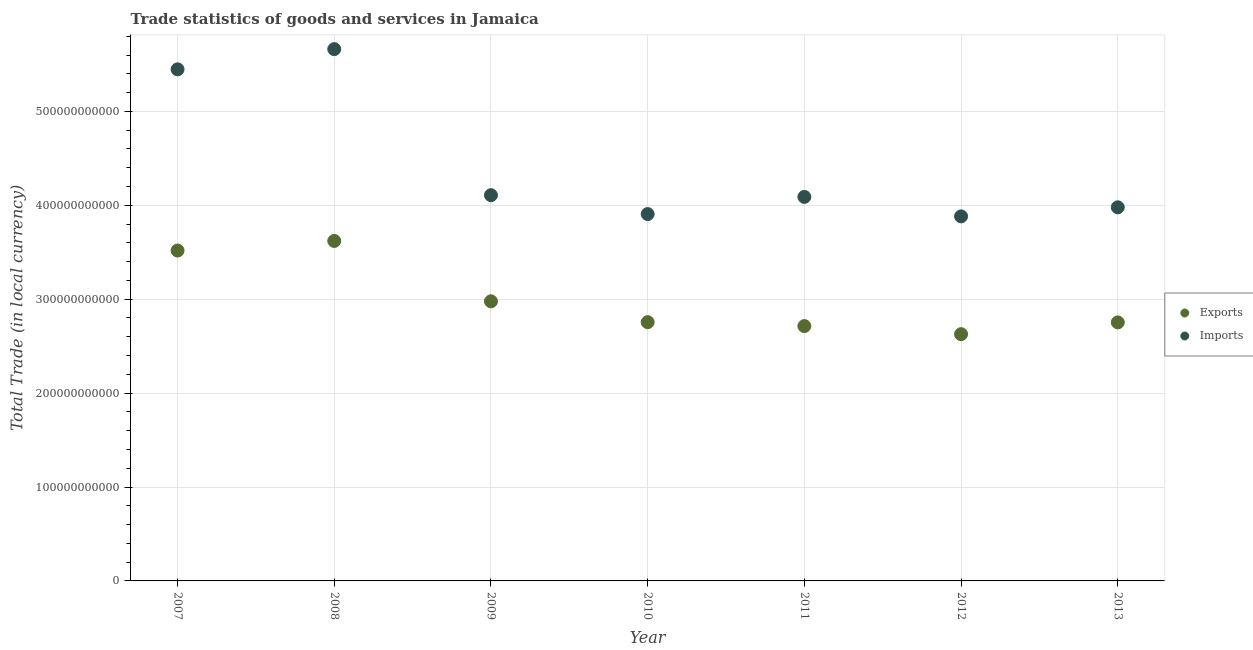What is the export of goods and services in 2009?
Offer a terse response. 2.98e+11. Across all years, what is the maximum export of goods and services?
Your answer should be very brief. 3.62e+11. Across all years, what is the minimum export of goods and services?
Your response must be concise. 2.63e+11. In which year was the imports of goods and services maximum?
Offer a very short reply. 2008. In which year was the imports of goods and services minimum?
Your answer should be very brief. 2012. What is the total export of goods and services in the graph?
Offer a very short reply. 2.10e+12. What is the difference between the export of goods and services in 2009 and that in 2010?
Offer a terse response. 2.22e+1. What is the difference between the imports of goods and services in 2013 and the export of goods and services in 2012?
Offer a terse response. 1.35e+11. What is the average imports of goods and services per year?
Ensure brevity in your answer.  4.44e+11. In the year 2008, what is the difference between the imports of goods and services and export of goods and services?
Give a very brief answer. 2.04e+11. What is the ratio of the imports of goods and services in 2009 to that in 2013?
Offer a very short reply. 1.03. Is the difference between the export of goods and services in 2009 and 2012 greater than the difference between the imports of goods and services in 2009 and 2012?
Offer a terse response. Yes. What is the difference between the highest and the second highest imports of goods and services?
Offer a very short reply. 2.15e+1. What is the difference between the highest and the lowest export of goods and services?
Your answer should be compact. 9.93e+1. Is the imports of goods and services strictly less than the export of goods and services over the years?
Your answer should be compact. No. What is the difference between two consecutive major ticks on the Y-axis?
Provide a succinct answer. 1.00e+11. Does the graph contain any zero values?
Your response must be concise. No. Where does the legend appear in the graph?
Offer a very short reply. Center right. How are the legend labels stacked?
Provide a short and direct response. Vertical. What is the title of the graph?
Offer a terse response. Trade statistics of goods and services in Jamaica. What is the label or title of the X-axis?
Make the answer very short. Year. What is the label or title of the Y-axis?
Ensure brevity in your answer.  Total Trade (in local currency). What is the Total Trade (in local currency) of Exports in 2007?
Offer a very short reply. 3.52e+11. What is the Total Trade (in local currency) of Imports in 2007?
Ensure brevity in your answer.  5.45e+11. What is the Total Trade (in local currency) of Exports in 2008?
Ensure brevity in your answer.  3.62e+11. What is the Total Trade (in local currency) in Imports in 2008?
Your response must be concise. 5.66e+11. What is the Total Trade (in local currency) in Exports in 2009?
Your answer should be compact. 2.98e+11. What is the Total Trade (in local currency) in Imports in 2009?
Make the answer very short. 4.11e+11. What is the Total Trade (in local currency) of Exports in 2010?
Offer a very short reply. 2.76e+11. What is the Total Trade (in local currency) of Imports in 2010?
Offer a terse response. 3.91e+11. What is the Total Trade (in local currency) of Exports in 2011?
Provide a succinct answer. 2.71e+11. What is the Total Trade (in local currency) of Imports in 2011?
Keep it short and to the point. 4.09e+11. What is the Total Trade (in local currency) of Exports in 2012?
Give a very brief answer. 2.63e+11. What is the Total Trade (in local currency) of Imports in 2012?
Make the answer very short. 3.88e+11. What is the Total Trade (in local currency) in Exports in 2013?
Provide a succinct answer. 2.75e+11. What is the Total Trade (in local currency) of Imports in 2013?
Your answer should be compact. 3.98e+11. Across all years, what is the maximum Total Trade (in local currency) of Exports?
Give a very brief answer. 3.62e+11. Across all years, what is the maximum Total Trade (in local currency) of Imports?
Your response must be concise. 5.66e+11. Across all years, what is the minimum Total Trade (in local currency) of Exports?
Offer a very short reply. 2.63e+11. Across all years, what is the minimum Total Trade (in local currency) in Imports?
Your response must be concise. 3.88e+11. What is the total Total Trade (in local currency) in Exports in the graph?
Offer a very short reply. 2.10e+12. What is the total Total Trade (in local currency) of Imports in the graph?
Ensure brevity in your answer.  3.11e+12. What is the difference between the Total Trade (in local currency) in Exports in 2007 and that in 2008?
Ensure brevity in your answer.  -1.02e+1. What is the difference between the Total Trade (in local currency) of Imports in 2007 and that in 2008?
Offer a very short reply. -2.15e+1. What is the difference between the Total Trade (in local currency) in Exports in 2007 and that in 2009?
Offer a very short reply. 5.41e+1. What is the difference between the Total Trade (in local currency) of Imports in 2007 and that in 2009?
Provide a succinct answer. 1.34e+11. What is the difference between the Total Trade (in local currency) of Exports in 2007 and that in 2010?
Offer a very short reply. 7.63e+1. What is the difference between the Total Trade (in local currency) in Imports in 2007 and that in 2010?
Keep it short and to the point. 1.54e+11. What is the difference between the Total Trade (in local currency) of Exports in 2007 and that in 2011?
Provide a short and direct response. 8.05e+1. What is the difference between the Total Trade (in local currency) in Imports in 2007 and that in 2011?
Your answer should be very brief. 1.36e+11. What is the difference between the Total Trade (in local currency) in Exports in 2007 and that in 2012?
Your answer should be very brief. 8.91e+1. What is the difference between the Total Trade (in local currency) of Imports in 2007 and that in 2012?
Offer a very short reply. 1.57e+11. What is the difference between the Total Trade (in local currency) of Exports in 2007 and that in 2013?
Provide a succinct answer. 7.65e+1. What is the difference between the Total Trade (in local currency) in Imports in 2007 and that in 2013?
Your answer should be compact. 1.47e+11. What is the difference between the Total Trade (in local currency) in Exports in 2008 and that in 2009?
Ensure brevity in your answer.  6.43e+1. What is the difference between the Total Trade (in local currency) of Imports in 2008 and that in 2009?
Give a very brief answer. 1.56e+11. What is the difference between the Total Trade (in local currency) in Exports in 2008 and that in 2010?
Keep it short and to the point. 8.65e+1. What is the difference between the Total Trade (in local currency) of Imports in 2008 and that in 2010?
Keep it short and to the point. 1.76e+11. What is the difference between the Total Trade (in local currency) in Exports in 2008 and that in 2011?
Provide a short and direct response. 9.07e+1. What is the difference between the Total Trade (in local currency) of Imports in 2008 and that in 2011?
Keep it short and to the point. 1.57e+11. What is the difference between the Total Trade (in local currency) in Exports in 2008 and that in 2012?
Give a very brief answer. 9.93e+1. What is the difference between the Total Trade (in local currency) of Imports in 2008 and that in 2012?
Offer a very short reply. 1.78e+11. What is the difference between the Total Trade (in local currency) in Exports in 2008 and that in 2013?
Give a very brief answer. 8.67e+1. What is the difference between the Total Trade (in local currency) of Imports in 2008 and that in 2013?
Make the answer very short. 1.68e+11. What is the difference between the Total Trade (in local currency) of Exports in 2009 and that in 2010?
Offer a terse response. 2.22e+1. What is the difference between the Total Trade (in local currency) in Imports in 2009 and that in 2010?
Make the answer very short. 2.01e+1. What is the difference between the Total Trade (in local currency) in Exports in 2009 and that in 2011?
Make the answer very short. 2.64e+1. What is the difference between the Total Trade (in local currency) of Imports in 2009 and that in 2011?
Your answer should be very brief. 1.80e+09. What is the difference between the Total Trade (in local currency) of Exports in 2009 and that in 2012?
Offer a very short reply. 3.50e+1. What is the difference between the Total Trade (in local currency) of Imports in 2009 and that in 2012?
Ensure brevity in your answer.  2.25e+1. What is the difference between the Total Trade (in local currency) of Exports in 2009 and that in 2013?
Give a very brief answer. 2.24e+1. What is the difference between the Total Trade (in local currency) in Imports in 2009 and that in 2013?
Provide a succinct answer. 1.29e+1. What is the difference between the Total Trade (in local currency) in Exports in 2010 and that in 2011?
Provide a short and direct response. 4.18e+09. What is the difference between the Total Trade (in local currency) in Imports in 2010 and that in 2011?
Ensure brevity in your answer.  -1.83e+1. What is the difference between the Total Trade (in local currency) of Exports in 2010 and that in 2012?
Your response must be concise. 1.28e+1. What is the difference between the Total Trade (in local currency) of Imports in 2010 and that in 2012?
Provide a succinct answer. 2.44e+09. What is the difference between the Total Trade (in local currency) of Exports in 2010 and that in 2013?
Your answer should be very brief. 2.34e+08. What is the difference between the Total Trade (in local currency) of Imports in 2010 and that in 2013?
Keep it short and to the point. -7.20e+09. What is the difference between the Total Trade (in local currency) of Exports in 2011 and that in 2012?
Offer a very short reply. 8.60e+09. What is the difference between the Total Trade (in local currency) of Imports in 2011 and that in 2012?
Ensure brevity in your answer.  2.07e+1. What is the difference between the Total Trade (in local currency) of Exports in 2011 and that in 2013?
Give a very brief answer. -3.94e+09. What is the difference between the Total Trade (in local currency) of Imports in 2011 and that in 2013?
Make the answer very short. 1.11e+1. What is the difference between the Total Trade (in local currency) of Exports in 2012 and that in 2013?
Provide a succinct answer. -1.25e+1. What is the difference between the Total Trade (in local currency) of Imports in 2012 and that in 2013?
Your response must be concise. -9.64e+09. What is the difference between the Total Trade (in local currency) in Exports in 2007 and the Total Trade (in local currency) in Imports in 2008?
Your answer should be very brief. -2.14e+11. What is the difference between the Total Trade (in local currency) of Exports in 2007 and the Total Trade (in local currency) of Imports in 2009?
Offer a terse response. -5.89e+1. What is the difference between the Total Trade (in local currency) of Exports in 2007 and the Total Trade (in local currency) of Imports in 2010?
Your answer should be very brief. -3.88e+1. What is the difference between the Total Trade (in local currency) in Exports in 2007 and the Total Trade (in local currency) in Imports in 2011?
Offer a terse response. -5.71e+1. What is the difference between the Total Trade (in local currency) in Exports in 2007 and the Total Trade (in local currency) in Imports in 2012?
Offer a very short reply. -3.64e+1. What is the difference between the Total Trade (in local currency) in Exports in 2007 and the Total Trade (in local currency) in Imports in 2013?
Your answer should be compact. -4.60e+1. What is the difference between the Total Trade (in local currency) of Exports in 2008 and the Total Trade (in local currency) of Imports in 2009?
Keep it short and to the point. -4.87e+1. What is the difference between the Total Trade (in local currency) in Exports in 2008 and the Total Trade (in local currency) in Imports in 2010?
Make the answer very short. -2.86e+1. What is the difference between the Total Trade (in local currency) in Exports in 2008 and the Total Trade (in local currency) in Imports in 2011?
Ensure brevity in your answer.  -4.69e+1. What is the difference between the Total Trade (in local currency) in Exports in 2008 and the Total Trade (in local currency) in Imports in 2012?
Your answer should be very brief. -2.62e+1. What is the difference between the Total Trade (in local currency) in Exports in 2008 and the Total Trade (in local currency) in Imports in 2013?
Your answer should be very brief. -3.58e+1. What is the difference between the Total Trade (in local currency) in Exports in 2009 and the Total Trade (in local currency) in Imports in 2010?
Your response must be concise. -9.29e+1. What is the difference between the Total Trade (in local currency) of Exports in 2009 and the Total Trade (in local currency) of Imports in 2011?
Your response must be concise. -1.11e+11. What is the difference between the Total Trade (in local currency) of Exports in 2009 and the Total Trade (in local currency) of Imports in 2012?
Ensure brevity in your answer.  -9.05e+1. What is the difference between the Total Trade (in local currency) in Exports in 2009 and the Total Trade (in local currency) in Imports in 2013?
Your answer should be compact. -1.00e+11. What is the difference between the Total Trade (in local currency) of Exports in 2010 and the Total Trade (in local currency) of Imports in 2011?
Offer a very short reply. -1.33e+11. What is the difference between the Total Trade (in local currency) in Exports in 2010 and the Total Trade (in local currency) in Imports in 2012?
Offer a very short reply. -1.13e+11. What is the difference between the Total Trade (in local currency) in Exports in 2010 and the Total Trade (in local currency) in Imports in 2013?
Your answer should be compact. -1.22e+11. What is the difference between the Total Trade (in local currency) of Exports in 2011 and the Total Trade (in local currency) of Imports in 2012?
Ensure brevity in your answer.  -1.17e+11. What is the difference between the Total Trade (in local currency) in Exports in 2011 and the Total Trade (in local currency) in Imports in 2013?
Make the answer very short. -1.26e+11. What is the difference between the Total Trade (in local currency) in Exports in 2012 and the Total Trade (in local currency) in Imports in 2013?
Offer a terse response. -1.35e+11. What is the average Total Trade (in local currency) of Exports per year?
Your response must be concise. 3.00e+11. What is the average Total Trade (in local currency) in Imports per year?
Your answer should be very brief. 4.44e+11. In the year 2007, what is the difference between the Total Trade (in local currency) of Exports and Total Trade (in local currency) of Imports?
Make the answer very short. -1.93e+11. In the year 2008, what is the difference between the Total Trade (in local currency) in Exports and Total Trade (in local currency) in Imports?
Provide a short and direct response. -2.04e+11. In the year 2009, what is the difference between the Total Trade (in local currency) in Exports and Total Trade (in local currency) in Imports?
Provide a succinct answer. -1.13e+11. In the year 2010, what is the difference between the Total Trade (in local currency) in Exports and Total Trade (in local currency) in Imports?
Offer a terse response. -1.15e+11. In the year 2011, what is the difference between the Total Trade (in local currency) in Exports and Total Trade (in local currency) in Imports?
Your answer should be compact. -1.38e+11. In the year 2012, what is the difference between the Total Trade (in local currency) in Exports and Total Trade (in local currency) in Imports?
Give a very brief answer. -1.25e+11. In the year 2013, what is the difference between the Total Trade (in local currency) in Exports and Total Trade (in local currency) in Imports?
Your answer should be very brief. -1.23e+11. What is the ratio of the Total Trade (in local currency) in Exports in 2007 to that in 2008?
Provide a short and direct response. 0.97. What is the ratio of the Total Trade (in local currency) in Imports in 2007 to that in 2008?
Provide a short and direct response. 0.96. What is the ratio of the Total Trade (in local currency) of Exports in 2007 to that in 2009?
Offer a terse response. 1.18. What is the ratio of the Total Trade (in local currency) in Imports in 2007 to that in 2009?
Offer a very short reply. 1.33. What is the ratio of the Total Trade (in local currency) of Exports in 2007 to that in 2010?
Keep it short and to the point. 1.28. What is the ratio of the Total Trade (in local currency) of Imports in 2007 to that in 2010?
Your answer should be compact. 1.39. What is the ratio of the Total Trade (in local currency) in Exports in 2007 to that in 2011?
Offer a very short reply. 1.3. What is the ratio of the Total Trade (in local currency) of Imports in 2007 to that in 2011?
Keep it short and to the point. 1.33. What is the ratio of the Total Trade (in local currency) in Exports in 2007 to that in 2012?
Your answer should be compact. 1.34. What is the ratio of the Total Trade (in local currency) of Imports in 2007 to that in 2012?
Your answer should be compact. 1.4. What is the ratio of the Total Trade (in local currency) of Exports in 2007 to that in 2013?
Ensure brevity in your answer.  1.28. What is the ratio of the Total Trade (in local currency) in Imports in 2007 to that in 2013?
Ensure brevity in your answer.  1.37. What is the ratio of the Total Trade (in local currency) of Exports in 2008 to that in 2009?
Make the answer very short. 1.22. What is the ratio of the Total Trade (in local currency) in Imports in 2008 to that in 2009?
Provide a succinct answer. 1.38. What is the ratio of the Total Trade (in local currency) of Exports in 2008 to that in 2010?
Your answer should be compact. 1.31. What is the ratio of the Total Trade (in local currency) of Imports in 2008 to that in 2010?
Your response must be concise. 1.45. What is the ratio of the Total Trade (in local currency) in Exports in 2008 to that in 2011?
Provide a succinct answer. 1.33. What is the ratio of the Total Trade (in local currency) in Imports in 2008 to that in 2011?
Provide a succinct answer. 1.38. What is the ratio of the Total Trade (in local currency) in Exports in 2008 to that in 2012?
Your response must be concise. 1.38. What is the ratio of the Total Trade (in local currency) in Imports in 2008 to that in 2012?
Offer a very short reply. 1.46. What is the ratio of the Total Trade (in local currency) in Exports in 2008 to that in 2013?
Provide a succinct answer. 1.31. What is the ratio of the Total Trade (in local currency) of Imports in 2008 to that in 2013?
Your answer should be very brief. 1.42. What is the ratio of the Total Trade (in local currency) in Exports in 2009 to that in 2010?
Ensure brevity in your answer.  1.08. What is the ratio of the Total Trade (in local currency) in Imports in 2009 to that in 2010?
Ensure brevity in your answer.  1.05. What is the ratio of the Total Trade (in local currency) of Exports in 2009 to that in 2011?
Offer a terse response. 1.1. What is the ratio of the Total Trade (in local currency) of Exports in 2009 to that in 2012?
Offer a terse response. 1.13. What is the ratio of the Total Trade (in local currency) of Imports in 2009 to that in 2012?
Provide a short and direct response. 1.06. What is the ratio of the Total Trade (in local currency) in Exports in 2009 to that in 2013?
Keep it short and to the point. 1.08. What is the ratio of the Total Trade (in local currency) of Imports in 2009 to that in 2013?
Provide a succinct answer. 1.03. What is the ratio of the Total Trade (in local currency) of Exports in 2010 to that in 2011?
Offer a very short reply. 1.02. What is the ratio of the Total Trade (in local currency) of Imports in 2010 to that in 2011?
Your response must be concise. 0.96. What is the ratio of the Total Trade (in local currency) in Exports in 2010 to that in 2012?
Offer a very short reply. 1.05. What is the ratio of the Total Trade (in local currency) of Imports in 2010 to that in 2013?
Make the answer very short. 0.98. What is the ratio of the Total Trade (in local currency) of Exports in 2011 to that in 2012?
Make the answer very short. 1.03. What is the ratio of the Total Trade (in local currency) in Imports in 2011 to that in 2012?
Give a very brief answer. 1.05. What is the ratio of the Total Trade (in local currency) of Exports in 2011 to that in 2013?
Provide a succinct answer. 0.99. What is the ratio of the Total Trade (in local currency) of Imports in 2011 to that in 2013?
Your answer should be very brief. 1.03. What is the ratio of the Total Trade (in local currency) of Exports in 2012 to that in 2013?
Ensure brevity in your answer.  0.95. What is the ratio of the Total Trade (in local currency) of Imports in 2012 to that in 2013?
Your response must be concise. 0.98. What is the difference between the highest and the second highest Total Trade (in local currency) in Exports?
Your answer should be compact. 1.02e+1. What is the difference between the highest and the second highest Total Trade (in local currency) in Imports?
Provide a succinct answer. 2.15e+1. What is the difference between the highest and the lowest Total Trade (in local currency) of Exports?
Offer a terse response. 9.93e+1. What is the difference between the highest and the lowest Total Trade (in local currency) in Imports?
Your answer should be compact. 1.78e+11. 